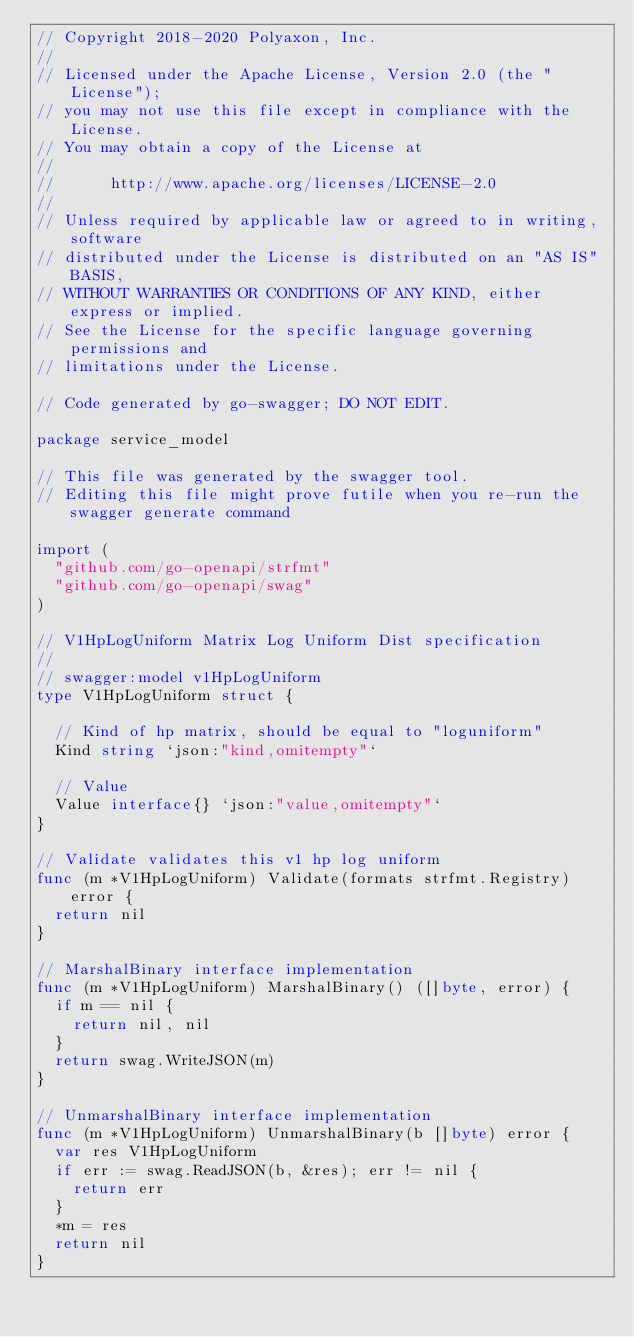Convert code to text. <code><loc_0><loc_0><loc_500><loc_500><_Go_>// Copyright 2018-2020 Polyaxon, Inc.
//
// Licensed under the Apache License, Version 2.0 (the "License");
// you may not use this file except in compliance with the License.
// You may obtain a copy of the License at
//
//      http://www.apache.org/licenses/LICENSE-2.0
//
// Unless required by applicable law or agreed to in writing, software
// distributed under the License is distributed on an "AS IS" BASIS,
// WITHOUT WARRANTIES OR CONDITIONS OF ANY KIND, either express or implied.
// See the License for the specific language governing permissions and
// limitations under the License.

// Code generated by go-swagger; DO NOT EDIT.

package service_model

// This file was generated by the swagger tool.
// Editing this file might prove futile when you re-run the swagger generate command

import (
	"github.com/go-openapi/strfmt"
	"github.com/go-openapi/swag"
)

// V1HpLogUniform Matrix Log Uniform Dist specification
//
// swagger:model v1HpLogUniform
type V1HpLogUniform struct {

	// Kind of hp matrix, should be equal to "loguniform"
	Kind string `json:"kind,omitempty"`

	// Value
	Value interface{} `json:"value,omitempty"`
}

// Validate validates this v1 hp log uniform
func (m *V1HpLogUniform) Validate(formats strfmt.Registry) error {
	return nil
}

// MarshalBinary interface implementation
func (m *V1HpLogUniform) MarshalBinary() ([]byte, error) {
	if m == nil {
		return nil, nil
	}
	return swag.WriteJSON(m)
}

// UnmarshalBinary interface implementation
func (m *V1HpLogUniform) UnmarshalBinary(b []byte) error {
	var res V1HpLogUniform
	if err := swag.ReadJSON(b, &res); err != nil {
		return err
	}
	*m = res
	return nil
}
</code> 